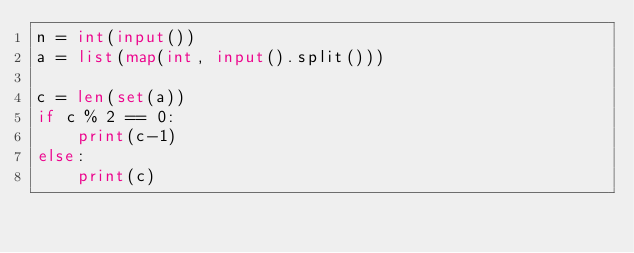<code> <loc_0><loc_0><loc_500><loc_500><_Python_>n = int(input())
a = list(map(int, input().split()))

c = len(set(a))
if c % 2 == 0:
    print(c-1)
else:
    print(c)</code> 